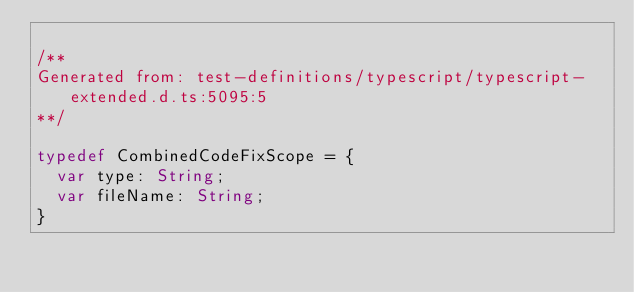Convert code to text. <code><loc_0><loc_0><loc_500><loc_500><_Haxe_>
/**
Generated from: test-definitions/typescript/typescript-extended.d.ts:5095:5
**/

typedef CombinedCodeFixScope = {
	var type: String;
	var fileName: String;
}

</code> 